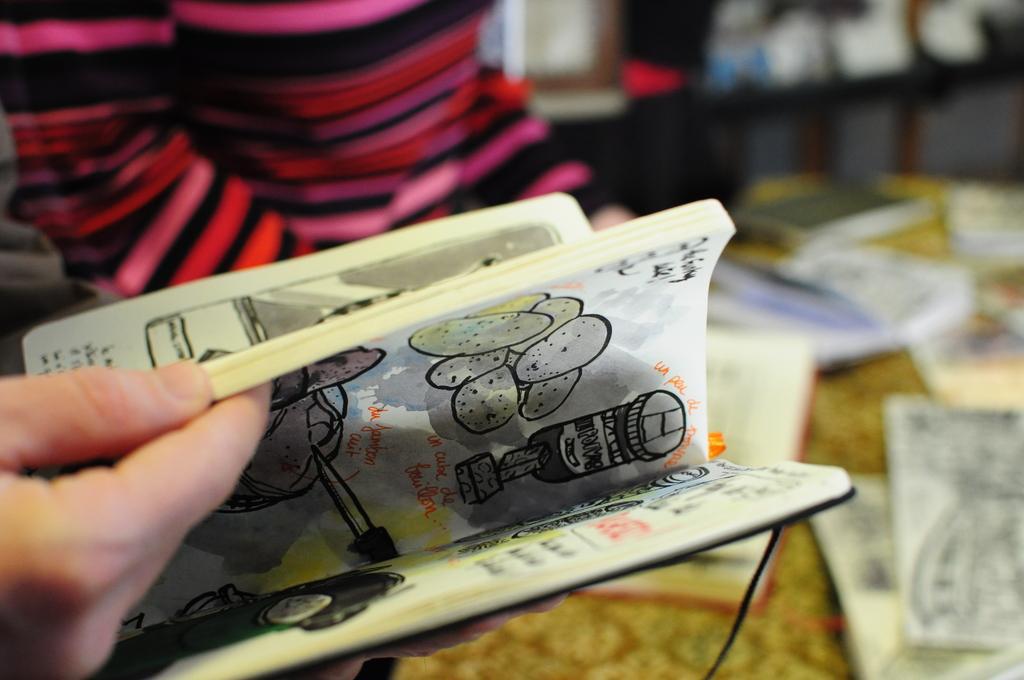How would you summarize this image in a sentence or two? In this image I can see the person and the person is holding the book and I can see the blurred background. 